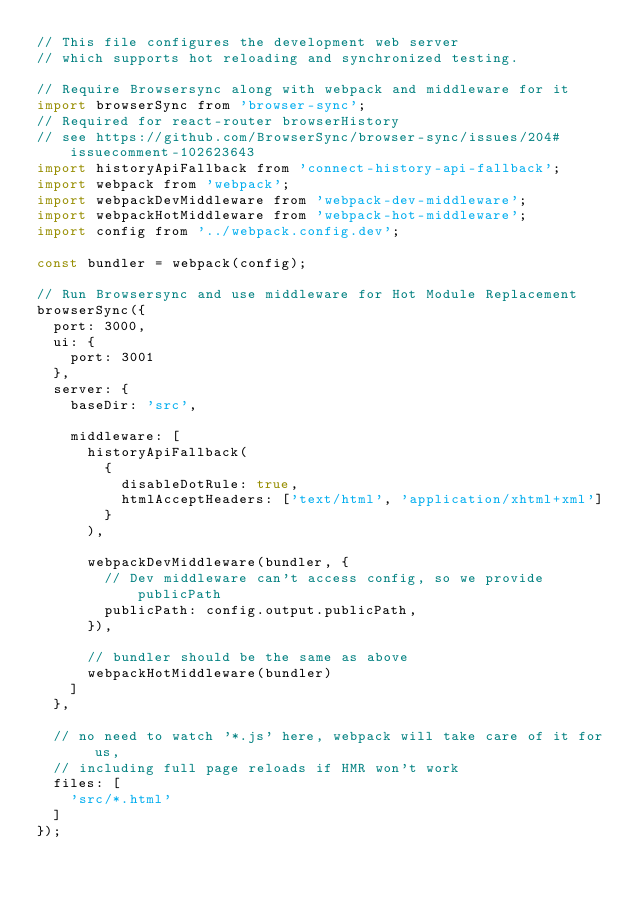<code> <loc_0><loc_0><loc_500><loc_500><_JavaScript_>// This file configures the development web server
// which supports hot reloading and synchronized testing.

// Require Browsersync along with webpack and middleware for it
import browserSync from 'browser-sync';
// Required for react-router browserHistory
// see https://github.com/BrowserSync/browser-sync/issues/204#issuecomment-102623643
import historyApiFallback from 'connect-history-api-fallback';
import webpack from 'webpack';
import webpackDevMiddleware from 'webpack-dev-middleware';
import webpackHotMiddleware from 'webpack-hot-middleware';
import config from '../webpack.config.dev';

const bundler = webpack(config);

// Run Browsersync and use middleware for Hot Module Replacement
browserSync({
  port: 3000,
  ui: {
    port: 3001
  },
  server: {
    baseDir: 'src',

    middleware: [
      historyApiFallback(
        {
          disableDotRule: true,
          htmlAcceptHeaders: ['text/html', 'application/xhtml+xml']
        }
      ),

      webpackDevMiddleware(bundler, {
        // Dev middleware can't access config, so we provide publicPath
        publicPath: config.output.publicPath,
      }),

      // bundler should be the same as above
      webpackHotMiddleware(bundler)
    ]
  },

  // no need to watch '*.js' here, webpack will take care of it for us,
  // including full page reloads if HMR won't work
  files: [
    'src/*.html'
  ]
});
</code> 